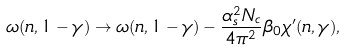Convert formula to latex. <formula><loc_0><loc_0><loc_500><loc_500>\omega ( n , 1 - \gamma ) \rightarrow \omega ( n , 1 - \gamma ) - \frac { \alpha _ { s } ^ { 2 } N _ { c } } { 4 \pi ^ { 2 } } \beta _ { 0 } \chi ^ { \prime } ( n , \gamma ) ,</formula> 